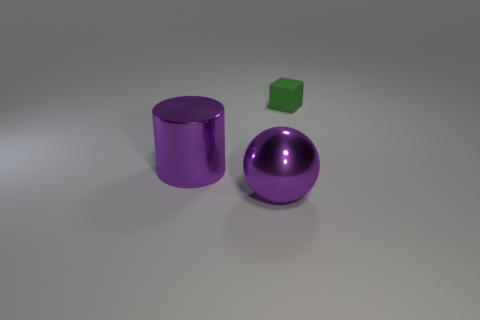Add 3 tiny cylinders. How many objects exist? 6 Subtract 0 cyan spheres. How many objects are left? 3 Subtract all cubes. How many objects are left? 2 Subtract all large matte things. Subtract all large metal things. How many objects are left? 1 Add 1 green rubber blocks. How many green rubber blocks are left? 2 Add 1 metallic things. How many metallic things exist? 3 